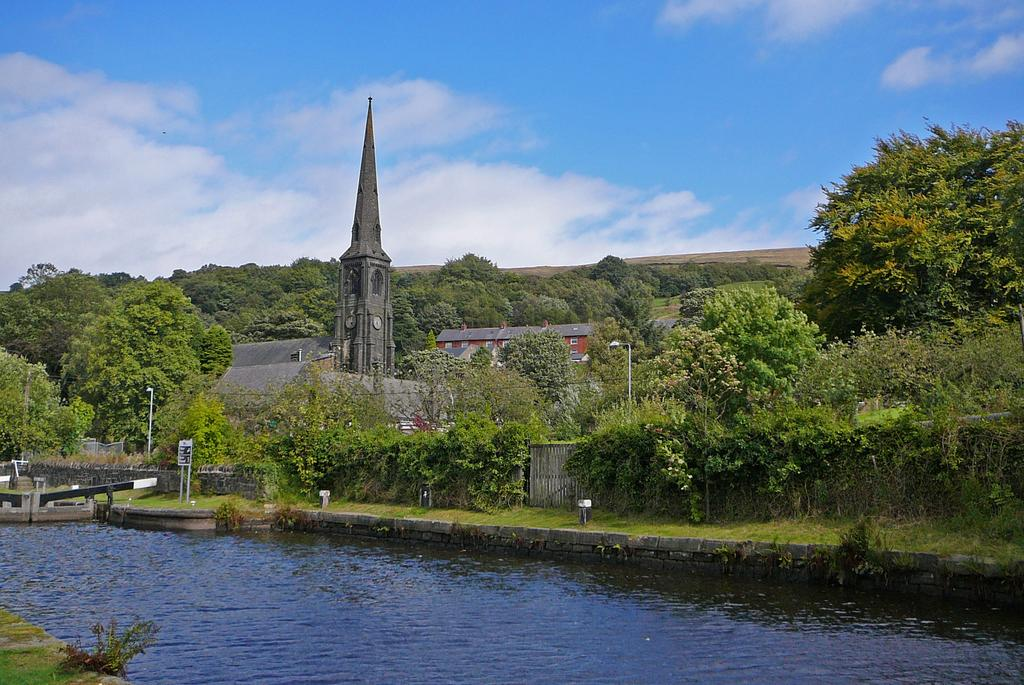What is the condition of the sky in the image? The sky is cloudy in the image. Where are the plants located in relation to the water? The plants are near the water in the image. What type of structures can be seen in the image? There are buildings and a clock tower in the image. What other natural elements are present in the image? There are trees in the image. What additional features can be observed in the image? There are light poles in the image. How many clocks are on the clock tower? There are clocks on the clock tower in the image. Can you tell me how many monkeys are pulling the light poles in the image? There are no monkeys present in the image, and they are not pulling any light poles. 